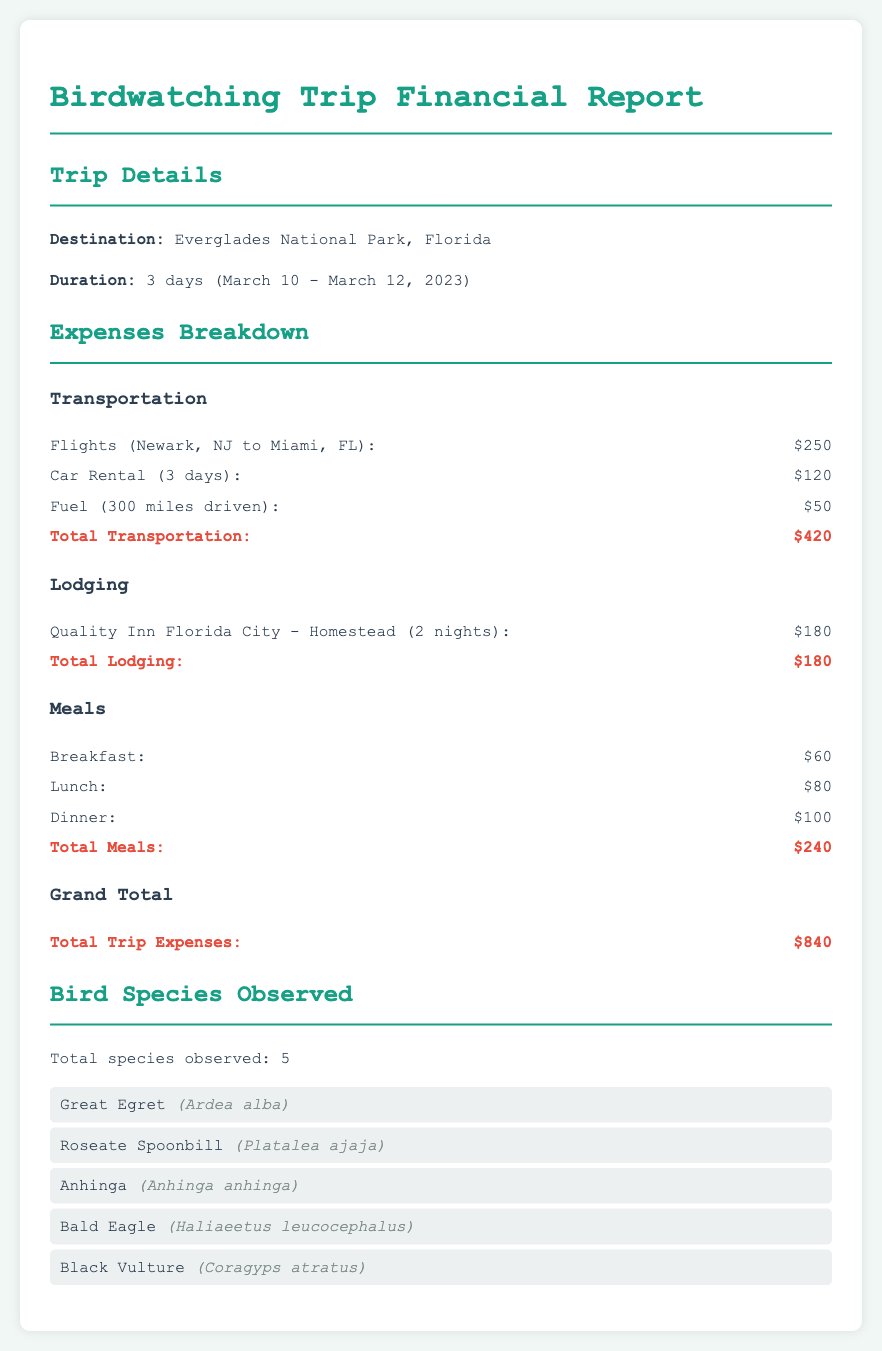What was the total amount spent on transportation? The total amount spent on transportation is listed under the transportation section, which is $420.
Answer: $420 How many meals were included in the report? The report specifies three types of meals: breakfast, lunch, and dinner, totaling three meals.
Answer: 3 What lodging was booked for the trip? The document mentions that the lodging booked was at Quality Inn Florida City - Homestead.
Answer: Quality Inn Florida City - Homestead What is the total cost for meals? The total cost for meals is detailed in the meals section as $240.
Answer: $240 What is the duration of the trip in days? The trip duration is explicitly stated as 3 days.
Answer: 3 days Which bird was observed that is known for its white feathers? The Great Egret is known for its white feathers and is listed as one of the observed species.
Answer: Great Egret What was the grand total expense for the trip? The grand total expense is the cumulative figure stated at the end of the expenses section, which is $840.
Answer: $840 How many bird species were observed during the trip? The document notes that a total of 5 bird species were observed.
Answer: 5 What type of report is this document? Based on the content, this document is a financial report related to travel expenses for birdwatching trips.
Answer: Financial report 